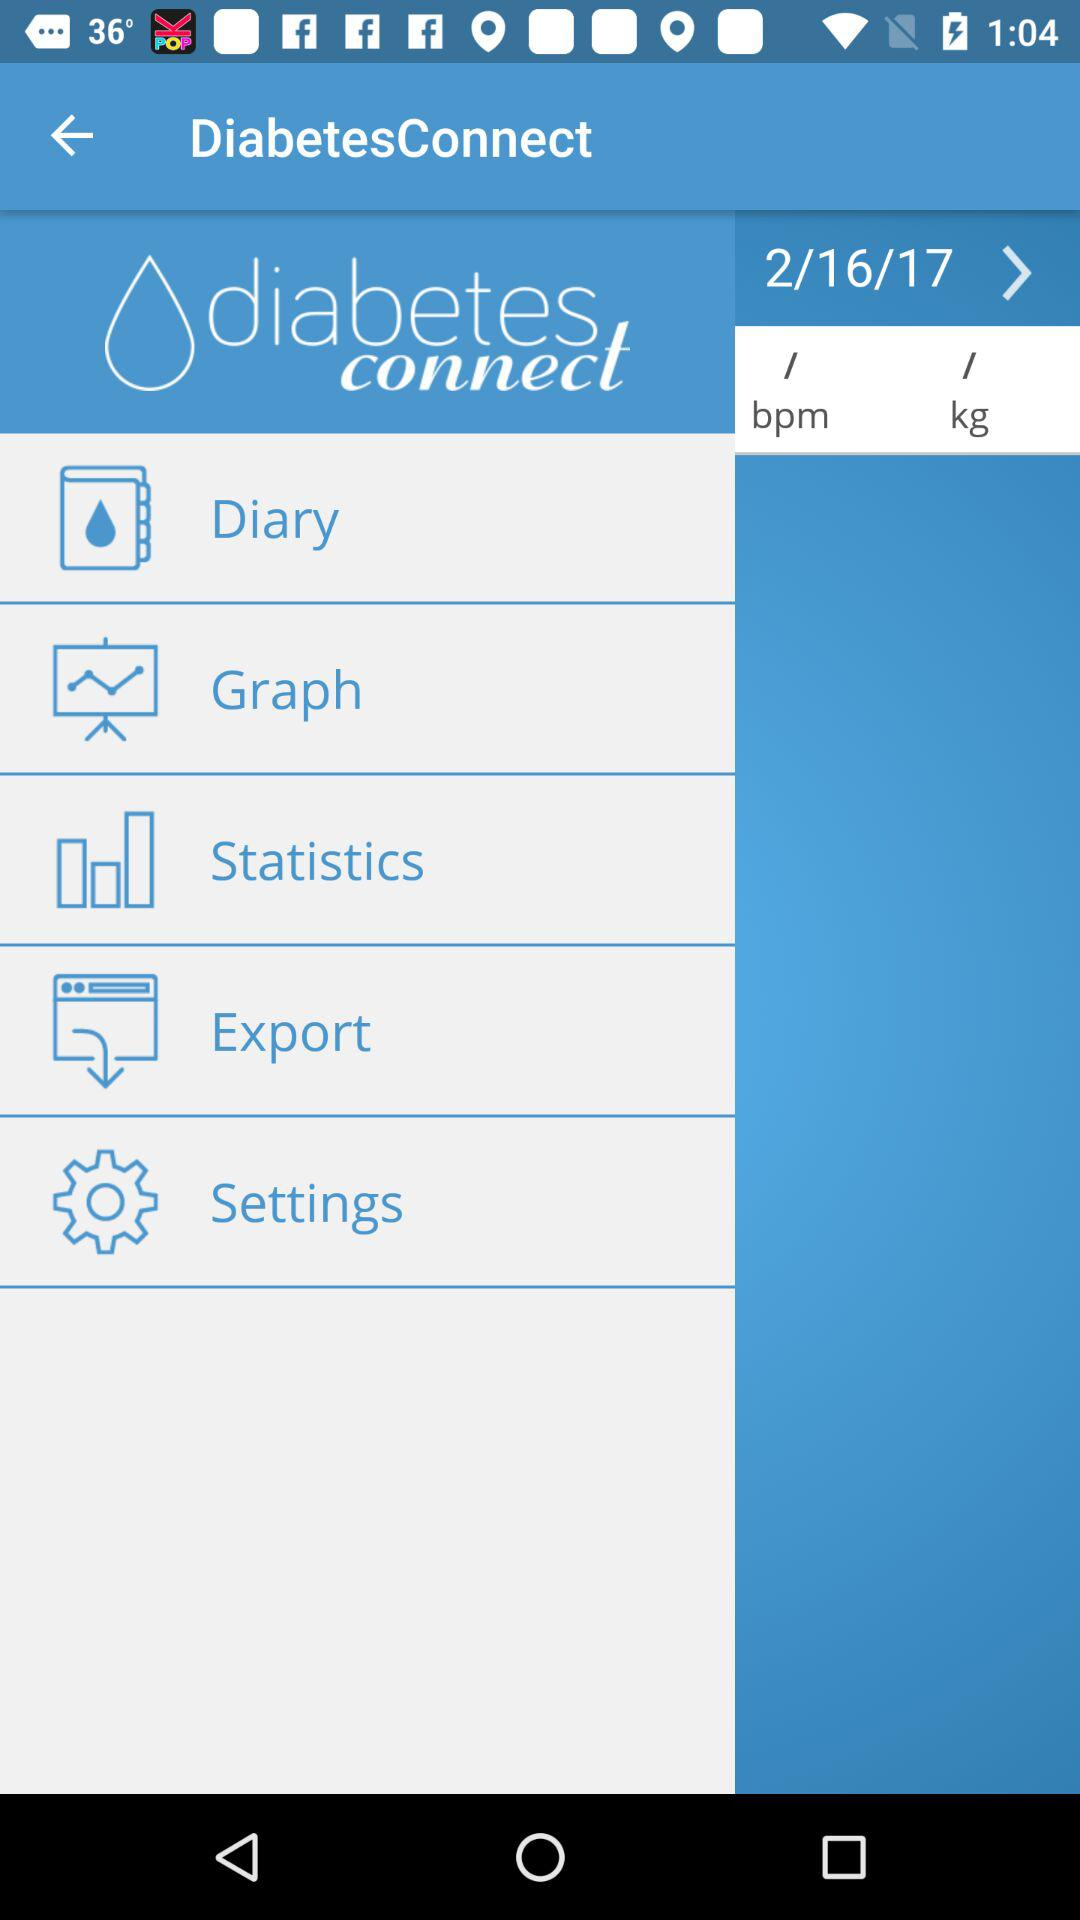What is the mentioned date? The mentioned date is February 16, 2017. 